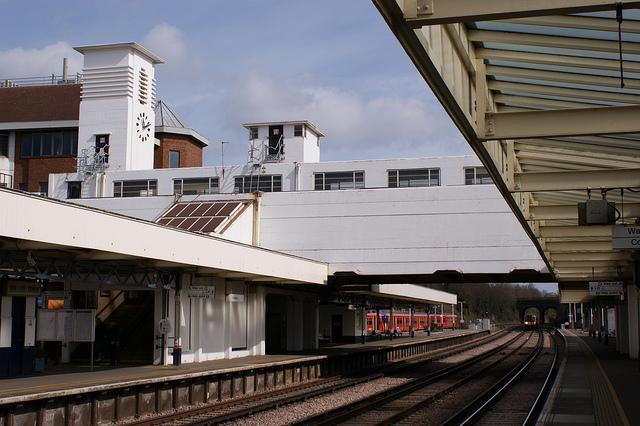How many bears are there?
Give a very brief answer. 0. 